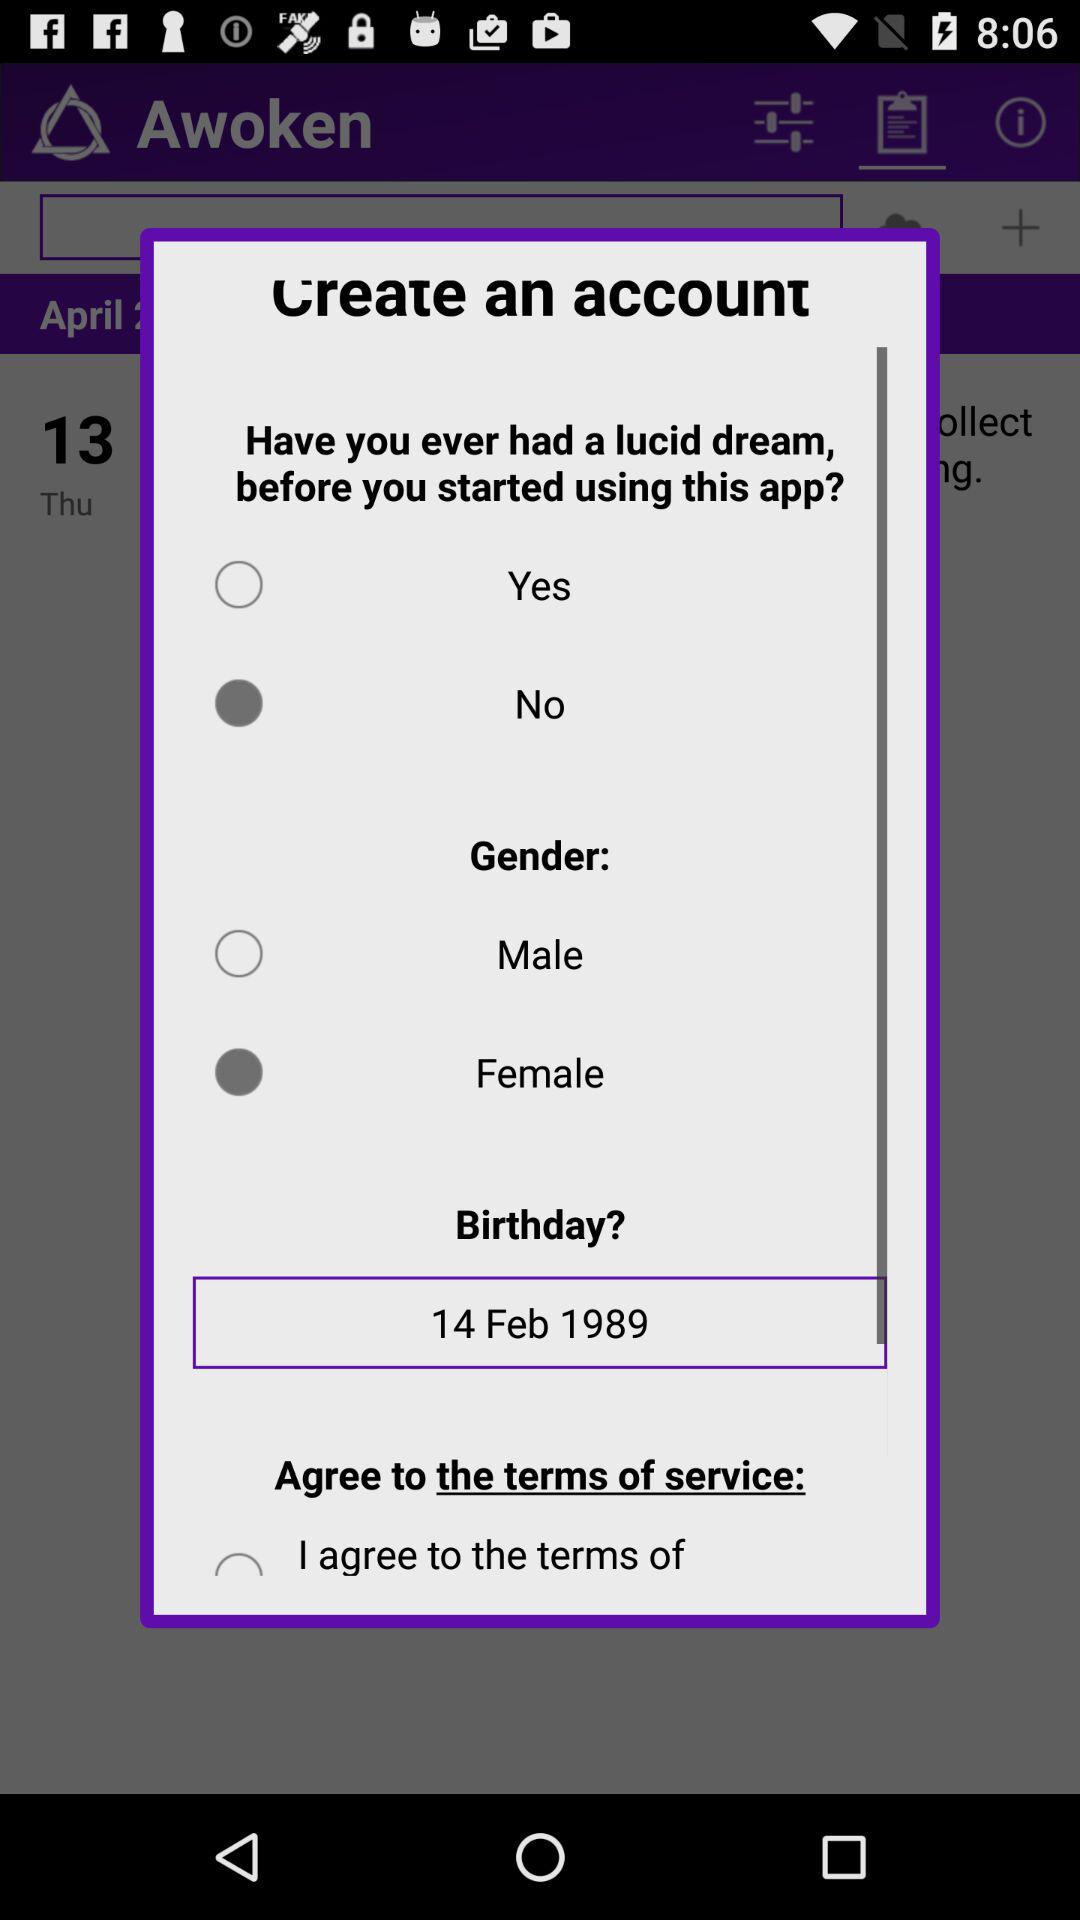How many options are there for gender?
Answer the question using a single word or phrase. 2 